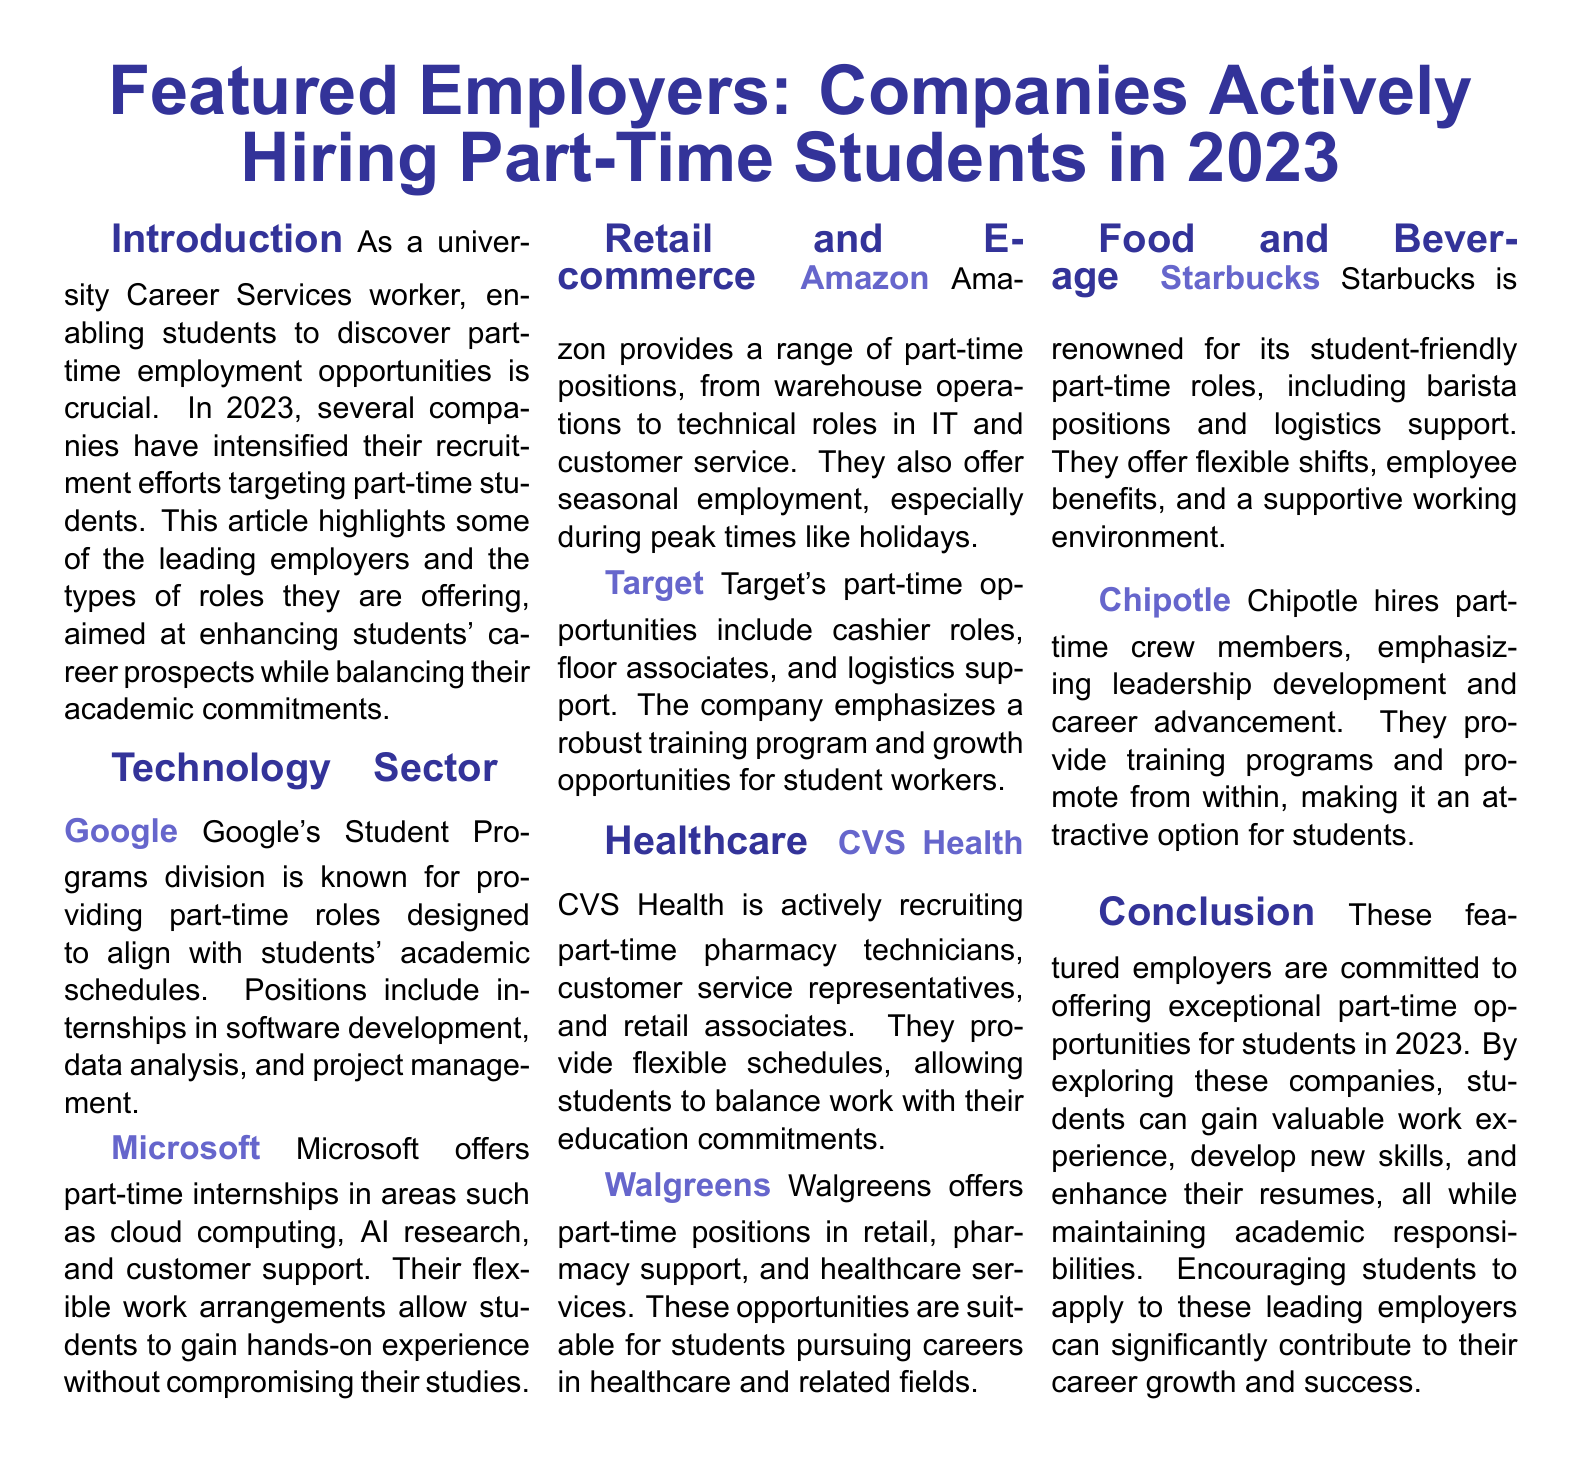what are the part-time roles offered by Google? Google offers part-time roles in internships such as software development, data analysis, and project management.
Answer: internships in software development, data analysis, and project management which company is known for its student-friendly roles? Starbucks is renowned for its student-friendly part-time roles.
Answer: Starbucks how many companies are highlighted in the Technology sector? The Technology sector highlights two companies: Google and Microsoft.
Answer: two what types of opportunities does CVS Health provide? CVS Health is actively recruiting part-time pharmacy technicians, customer service representatives, and retail associates.
Answer: pharmacy technicians, customer service representatives, and retail associates what is the emphasis of Target for student workers? Target emphasizes a robust training program and growth opportunities for student workers.
Answer: robust training program and growth opportunities which employer offers seasonal employment? Amazon offers seasonal employment, especially during peak times like holidays.
Answer: Amazon what is a reason Chipotle is an attractive option for students? Chipotle provides training programs and promotes from within, emphasizing leadership development and career advancement.
Answer: emphasizes leadership development and career advancement which sector does Walgreens belong to? Walgreens is in the Healthcare sector, offering part-time positions related to retail and pharmacy support.
Answer: Healthcare where can students gain hands-on experience with flexible work arrangements? Students can gain hands-on experience with flexible work arrangements at Microsoft.
Answer: Microsoft 